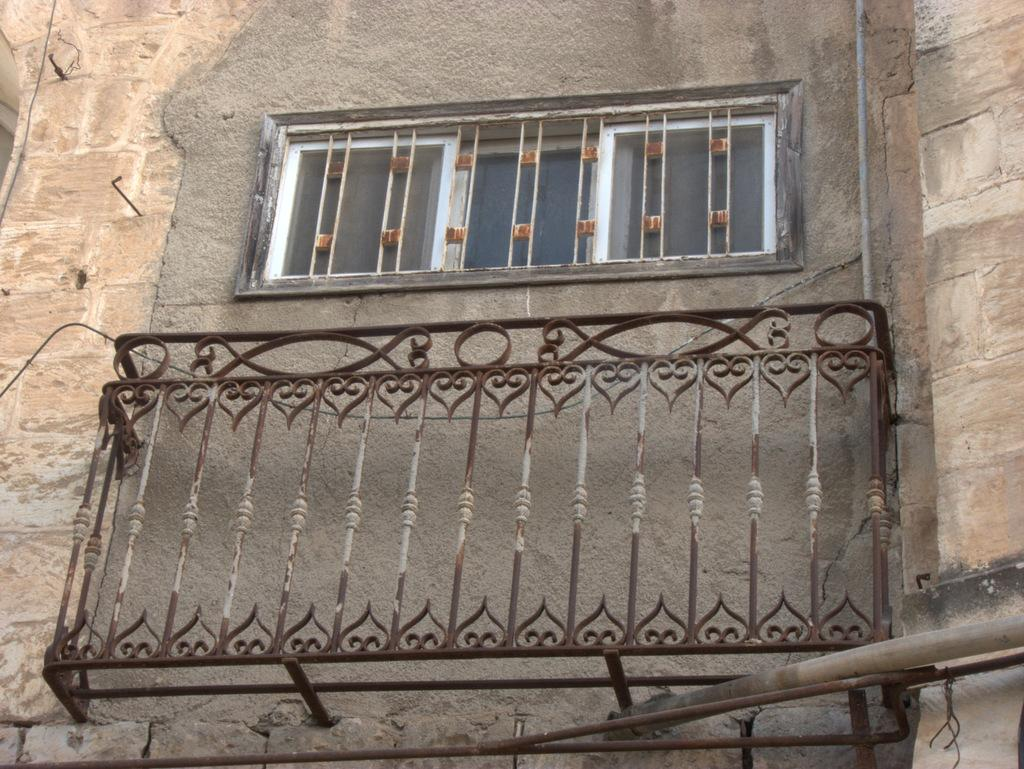What is the person in the image holding? The person is holding a phone. What is located near the person in the image? The person is standing near a tree. What type of stem can be seen growing from the tree in the image? There is no stem visible in the image, as the focus is on the person holding a phone and standing near the tree. 